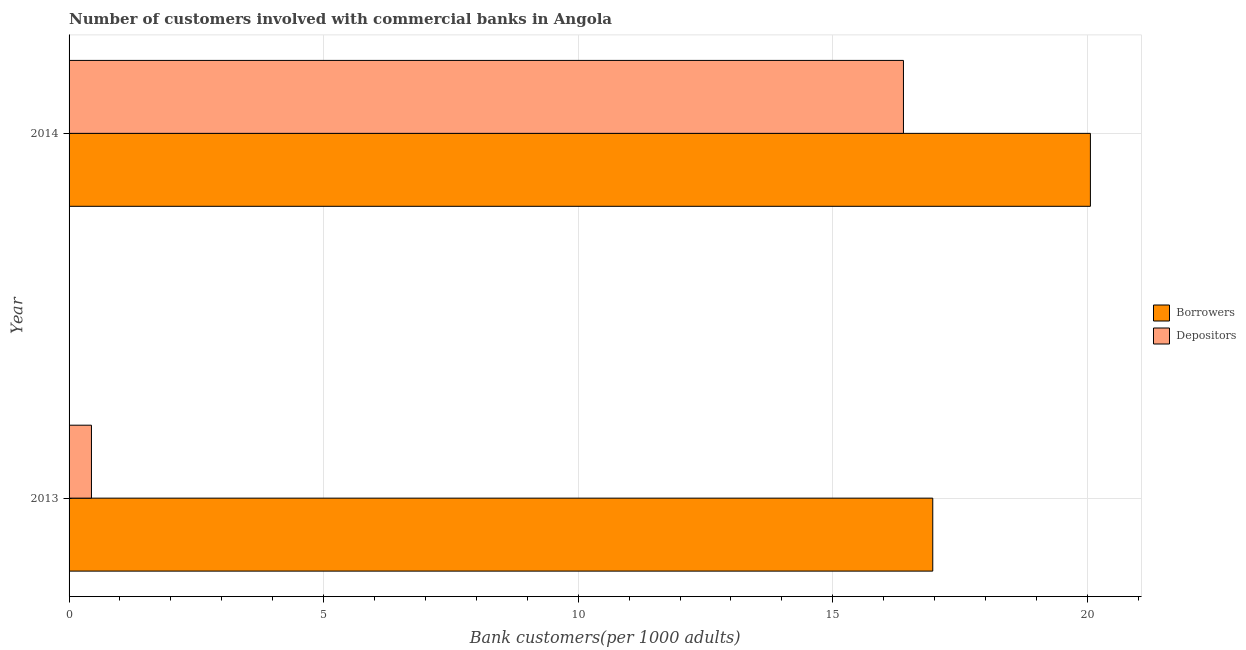How many different coloured bars are there?
Offer a terse response. 2. How many groups of bars are there?
Your response must be concise. 2. How many bars are there on the 2nd tick from the top?
Give a very brief answer. 2. What is the number of borrowers in 2013?
Make the answer very short. 16.96. Across all years, what is the maximum number of depositors?
Offer a very short reply. 16.39. Across all years, what is the minimum number of borrowers?
Your answer should be very brief. 16.96. In which year was the number of borrowers minimum?
Keep it short and to the point. 2013. What is the total number of depositors in the graph?
Your answer should be very brief. 16.83. What is the difference between the number of depositors in 2013 and that in 2014?
Ensure brevity in your answer.  -15.95. What is the difference between the number of depositors in 2014 and the number of borrowers in 2013?
Give a very brief answer. -0.58. What is the average number of depositors per year?
Make the answer very short. 8.41. In the year 2014, what is the difference between the number of borrowers and number of depositors?
Ensure brevity in your answer.  3.67. What is the ratio of the number of depositors in 2013 to that in 2014?
Offer a terse response. 0.03. Is the difference between the number of borrowers in 2013 and 2014 greater than the difference between the number of depositors in 2013 and 2014?
Make the answer very short. Yes. In how many years, is the number of depositors greater than the average number of depositors taken over all years?
Make the answer very short. 1. What does the 1st bar from the top in 2013 represents?
Make the answer very short. Depositors. What does the 1st bar from the bottom in 2014 represents?
Your response must be concise. Borrowers. Are all the bars in the graph horizontal?
Offer a terse response. Yes. What is the difference between two consecutive major ticks on the X-axis?
Your answer should be very brief. 5. Are the values on the major ticks of X-axis written in scientific E-notation?
Make the answer very short. No. Does the graph contain grids?
Offer a terse response. Yes. How many legend labels are there?
Keep it short and to the point. 2. How are the legend labels stacked?
Your answer should be compact. Vertical. What is the title of the graph?
Ensure brevity in your answer.  Number of customers involved with commercial banks in Angola. Does "Working capital" appear as one of the legend labels in the graph?
Ensure brevity in your answer.  No. What is the label or title of the X-axis?
Keep it short and to the point. Bank customers(per 1000 adults). What is the Bank customers(per 1000 adults) of Borrowers in 2013?
Offer a terse response. 16.96. What is the Bank customers(per 1000 adults) of Depositors in 2013?
Your answer should be compact. 0.44. What is the Bank customers(per 1000 adults) in Borrowers in 2014?
Make the answer very short. 20.06. What is the Bank customers(per 1000 adults) of Depositors in 2014?
Offer a terse response. 16.39. Across all years, what is the maximum Bank customers(per 1000 adults) of Borrowers?
Your answer should be very brief. 20.06. Across all years, what is the maximum Bank customers(per 1000 adults) in Depositors?
Provide a succinct answer. 16.39. Across all years, what is the minimum Bank customers(per 1000 adults) in Borrowers?
Make the answer very short. 16.96. Across all years, what is the minimum Bank customers(per 1000 adults) of Depositors?
Your answer should be compact. 0.44. What is the total Bank customers(per 1000 adults) in Borrowers in the graph?
Make the answer very short. 37.02. What is the total Bank customers(per 1000 adults) of Depositors in the graph?
Offer a very short reply. 16.83. What is the difference between the Bank customers(per 1000 adults) in Borrowers in 2013 and that in 2014?
Keep it short and to the point. -3.1. What is the difference between the Bank customers(per 1000 adults) of Depositors in 2013 and that in 2014?
Ensure brevity in your answer.  -15.95. What is the difference between the Bank customers(per 1000 adults) of Borrowers in 2013 and the Bank customers(per 1000 adults) of Depositors in 2014?
Provide a succinct answer. 0.58. What is the average Bank customers(per 1000 adults) of Borrowers per year?
Your answer should be compact. 18.51. What is the average Bank customers(per 1000 adults) of Depositors per year?
Keep it short and to the point. 8.41. In the year 2013, what is the difference between the Bank customers(per 1000 adults) of Borrowers and Bank customers(per 1000 adults) of Depositors?
Offer a very short reply. 16.52. In the year 2014, what is the difference between the Bank customers(per 1000 adults) in Borrowers and Bank customers(per 1000 adults) in Depositors?
Offer a very short reply. 3.67. What is the ratio of the Bank customers(per 1000 adults) of Borrowers in 2013 to that in 2014?
Make the answer very short. 0.85. What is the ratio of the Bank customers(per 1000 adults) of Depositors in 2013 to that in 2014?
Ensure brevity in your answer.  0.03. What is the difference between the highest and the second highest Bank customers(per 1000 adults) in Borrowers?
Make the answer very short. 3.1. What is the difference between the highest and the second highest Bank customers(per 1000 adults) of Depositors?
Offer a very short reply. 15.95. What is the difference between the highest and the lowest Bank customers(per 1000 adults) in Borrowers?
Provide a short and direct response. 3.1. What is the difference between the highest and the lowest Bank customers(per 1000 adults) of Depositors?
Provide a succinct answer. 15.95. 